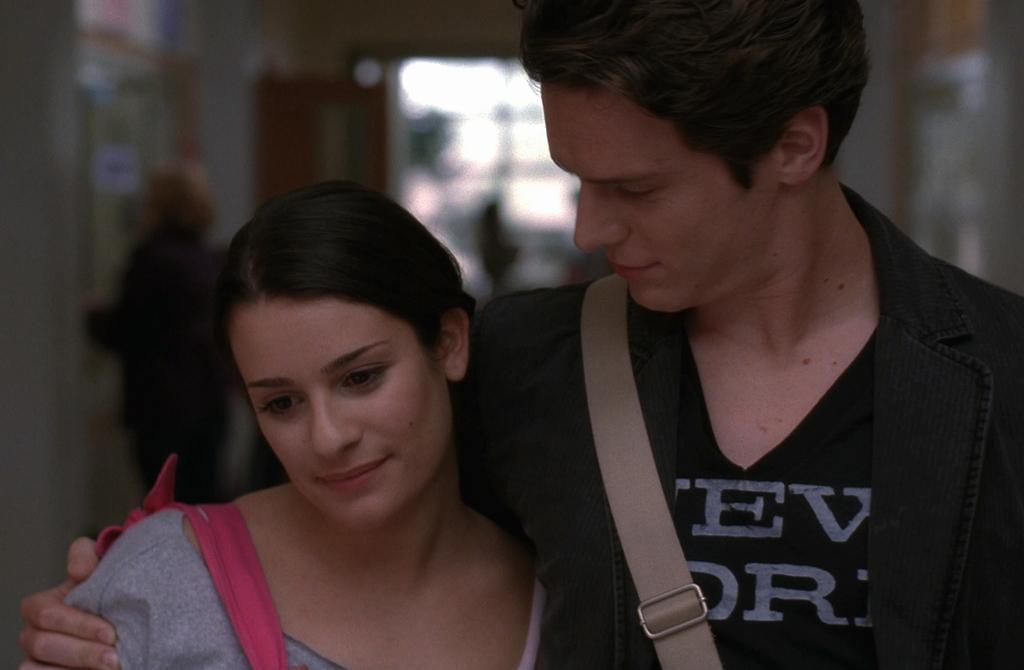Describe this image in one or two sentences. In this image I can see two persons in the front and I can see both of them are carrying bags. On the right side of the image I can see one of them is wearing the black colour dress and on the left side I can see one of them is wearing a grey colour dress. In the background I can see few more people and I can also see this image is blurry in the background. 